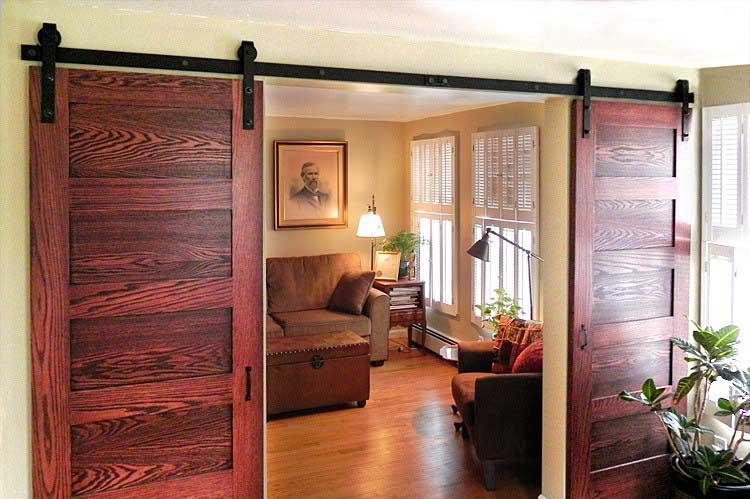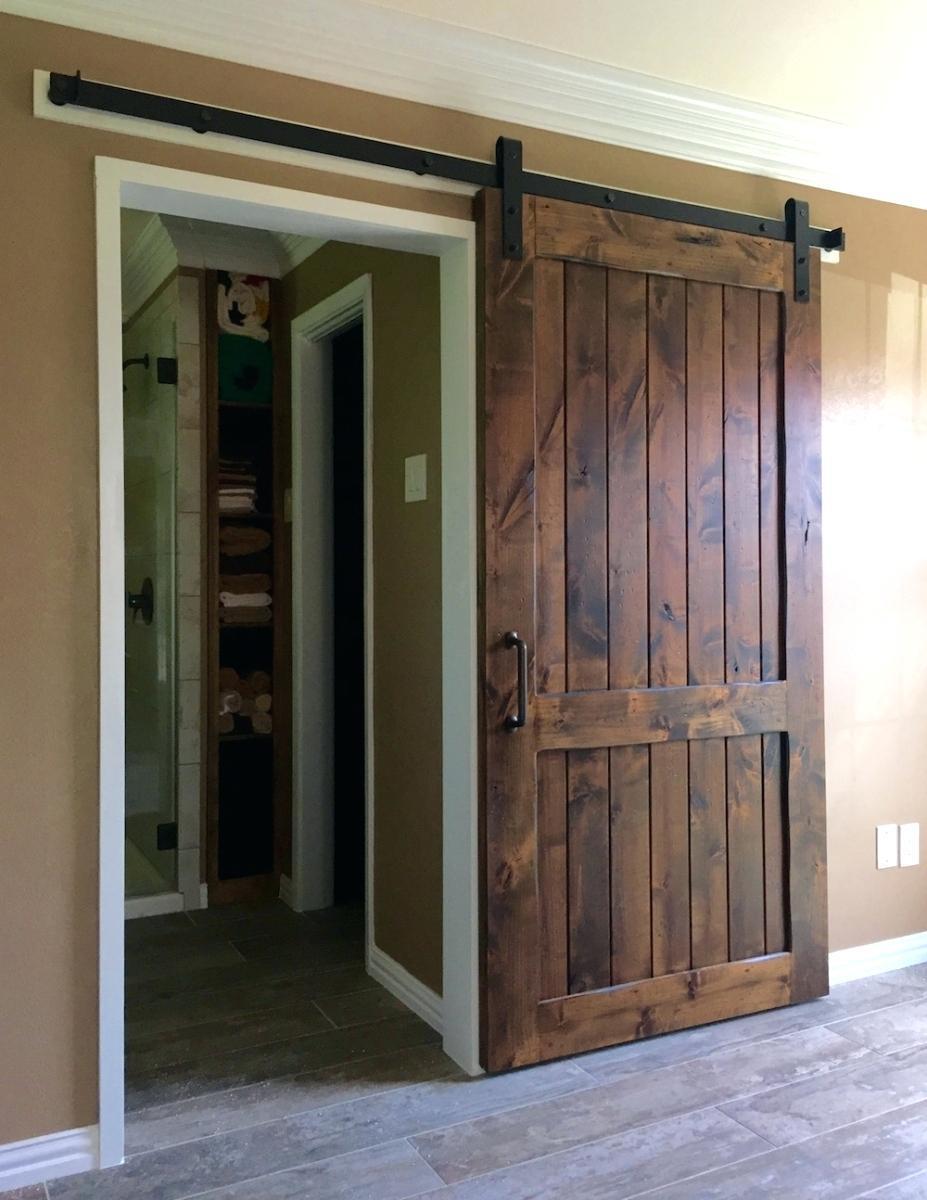The first image is the image on the left, the second image is the image on the right. For the images displayed, is the sentence "One door is open in the center, the other is open to the side." factually correct? Answer yes or no. Yes. 